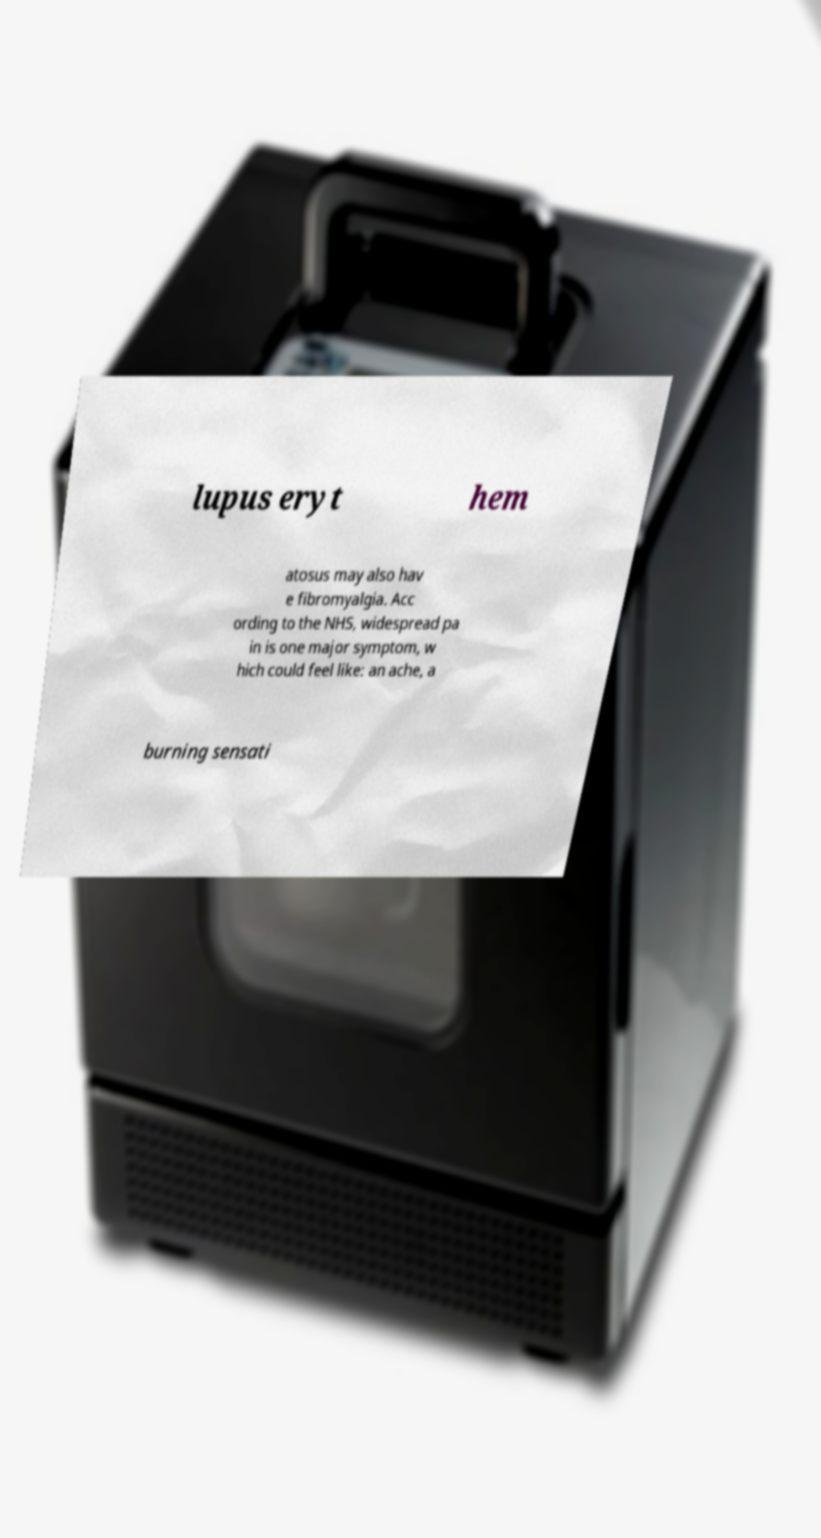What messages or text are displayed in this image? I need them in a readable, typed format. lupus eryt hem atosus may also hav e fibromyalgia. Acc ording to the NHS, widespread pa in is one major symptom, w hich could feel like: an ache, a burning sensati 